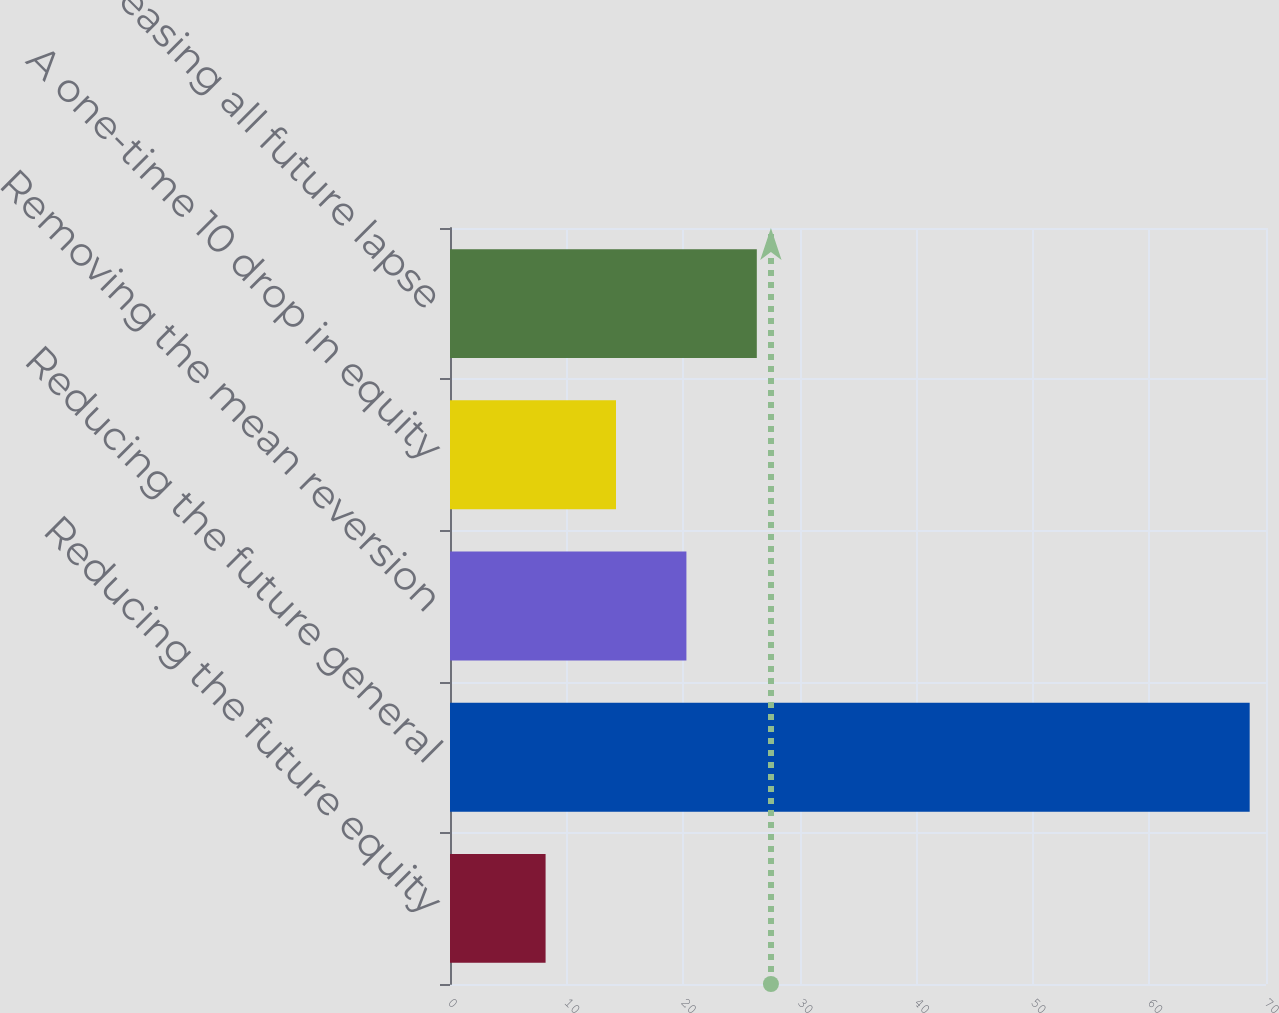Convert chart to OTSL. <chart><loc_0><loc_0><loc_500><loc_500><bar_chart><fcel>Reducing the future equity<fcel>Reducing the future general<fcel>Removing the mean reversion<fcel>A one-time 10 drop in equity<fcel>Increasing all future lapse<nl><fcel>8.2<fcel>68.6<fcel>20.28<fcel>14.24<fcel>26.32<nl></chart> 